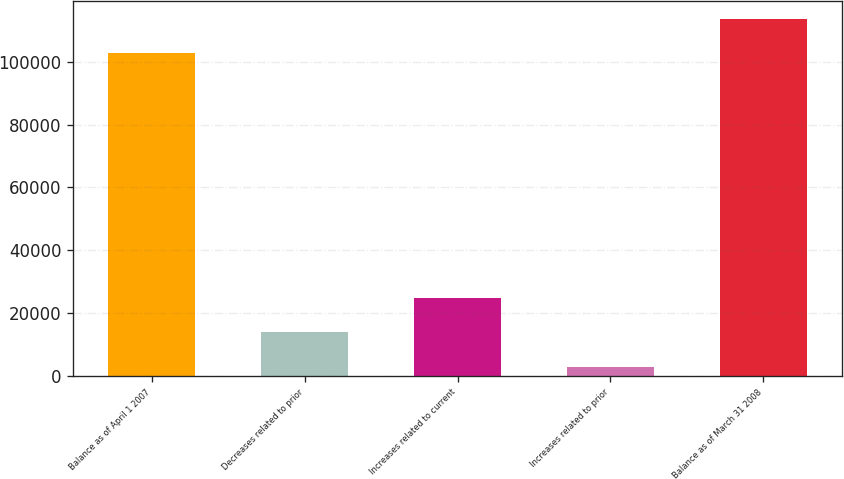<chart> <loc_0><loc_0><loc_500><loc_500><bar_chart><fcel>Balance as of April 1 2007<fcel>Decreases related to prior<fcel>Increases related to current<fcel>Increases related to prior<fcel>Balance as of March 31 2008<nl><fcel>102757<fcel>13878.9<fcel>24815.8<fcel>2942<fcel>113694<nl></chart> 